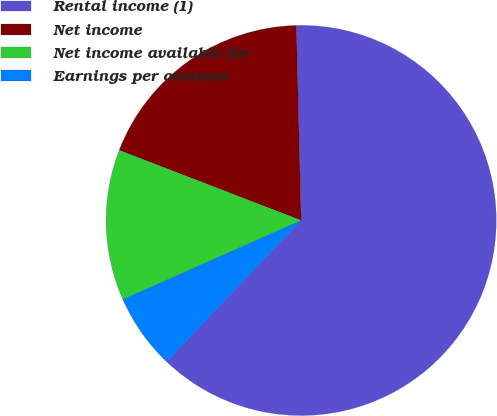Convert chart. <chart><loc_0><loc_0><loc_500><loc_500><pie_chart><fcel>Rental income (1)<fcel>Net income<fcel>Net income available for<fcel>Earnings per common<nl><fcel>62.5%<fcel>18.75%<fcel>12.5%<fcel>6.25%<nl></chart> 